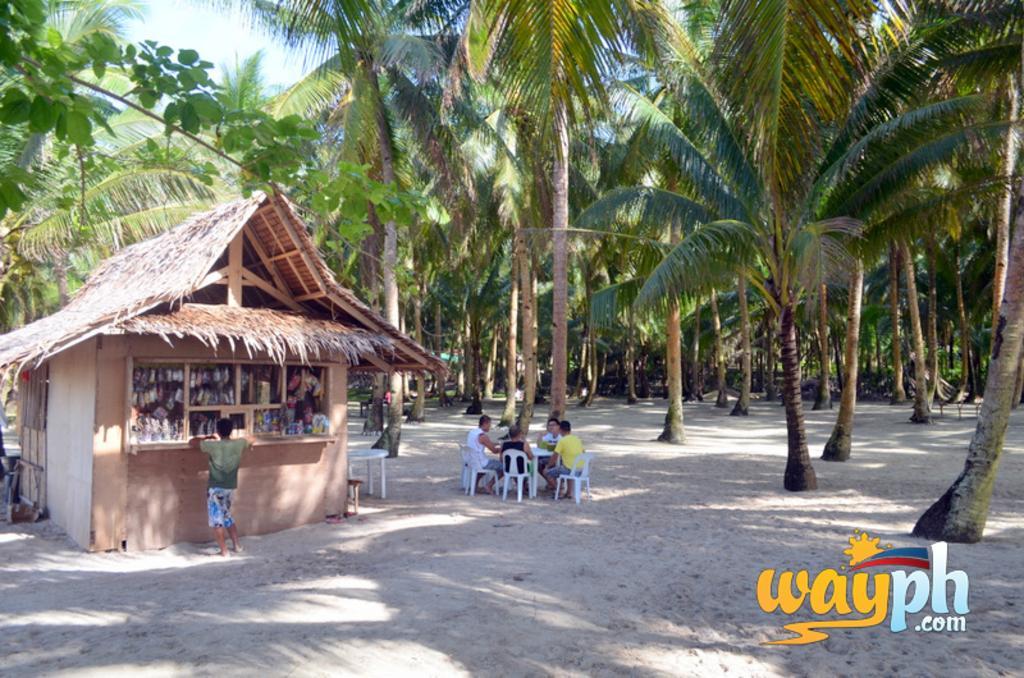Describe this image in one or two sentences. In this image I can see small house in front of house I can see a person and in the middle there is a table, around the table there are some persons sitting in the chair ,there is another table visible beside the house and there are some trees visible in the middle ,in the bottom right there is a text visible. 